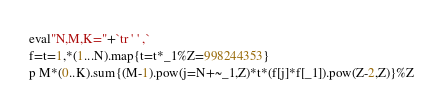Convert code to text. <code><loc_0><loc_0><loc_500><loc_500><_Ruby_>eval"N,M,K="+`tr ' ' ,`
f=t=1,*(1...N).map{t=t*_1%Z=998244353}
p M*(0..K).sum{(M-1).pow(j=N+~_1,Z)*t*(f[j]*f[_1]).pow(Z-2,Z)}%Z</code> 